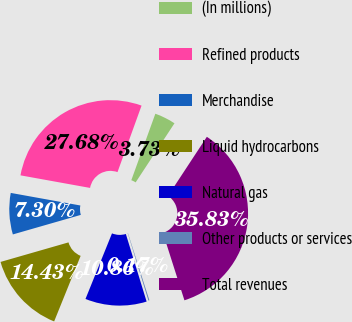Convert chart. <chart><loc_0><loc_0><loc_500><loc_500><pie_chart><fcel>(In millions)<fcel>Refined products<fcel>Merchandise<fcel>Liquid hydrocarbons<fcel>Natural gas<fcel>Other products or services<fcel>Total revenues<nl><fcel>3.73%<fcel>27.68%<fcel>7.3%<fcel>14.43%<fcel>10.86%<fcel>0.17%<fcel>35.83%<nl></chart> 